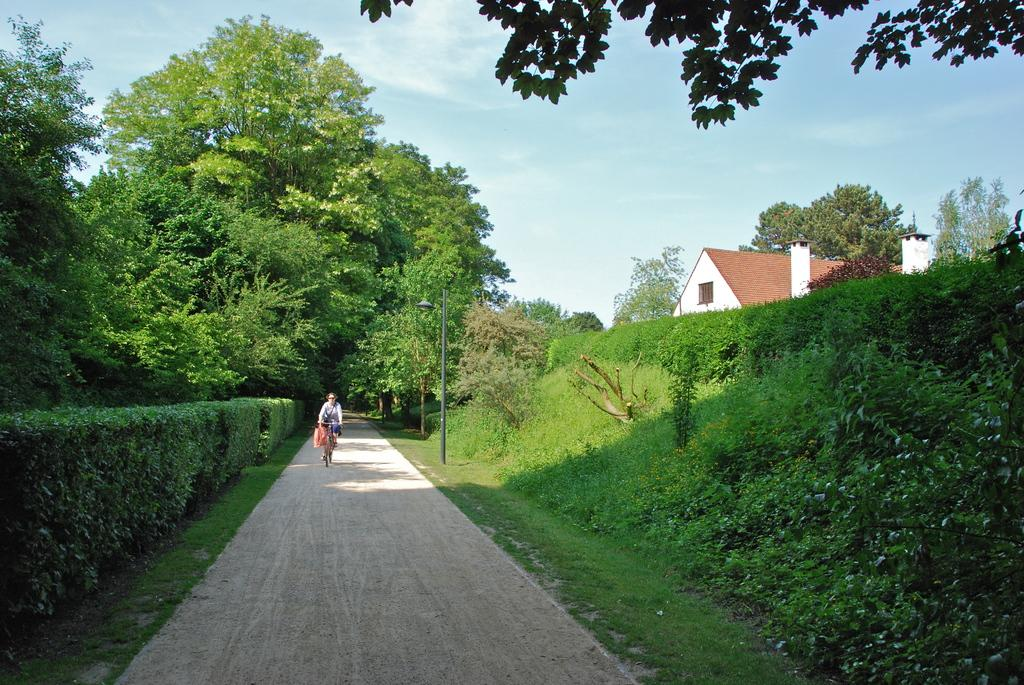What is the person in the image doing? There is a person riding a bicycle in the image. What type of vegetation can be seen in the image? There are shrubs and trees in the image. What object is present in the image that might be used for support or guidance? There is a pole in the image. Where is the house located in the image? There is a house on the right side of the image. What type of plantation is visible in the image? There is no plantation present in the image. What type of bike is the person riding in the image? The facts provided do not specify the type of bike the person is riding. 